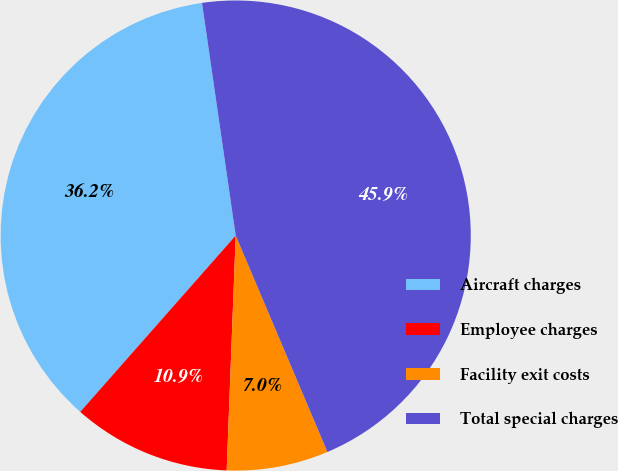Convert chart to OTSL. <chart><loc_0><loc_0><loc_500><loc_500><pie_chart><fcel>Aircraft charges<fcel>Employee charges<fcel>Facility exit costs<fcel>Total special charges<nl><fcel>36.21%<fcel>10.89%<fcel>6.99%<fcel>45.91%<nl></chart> 